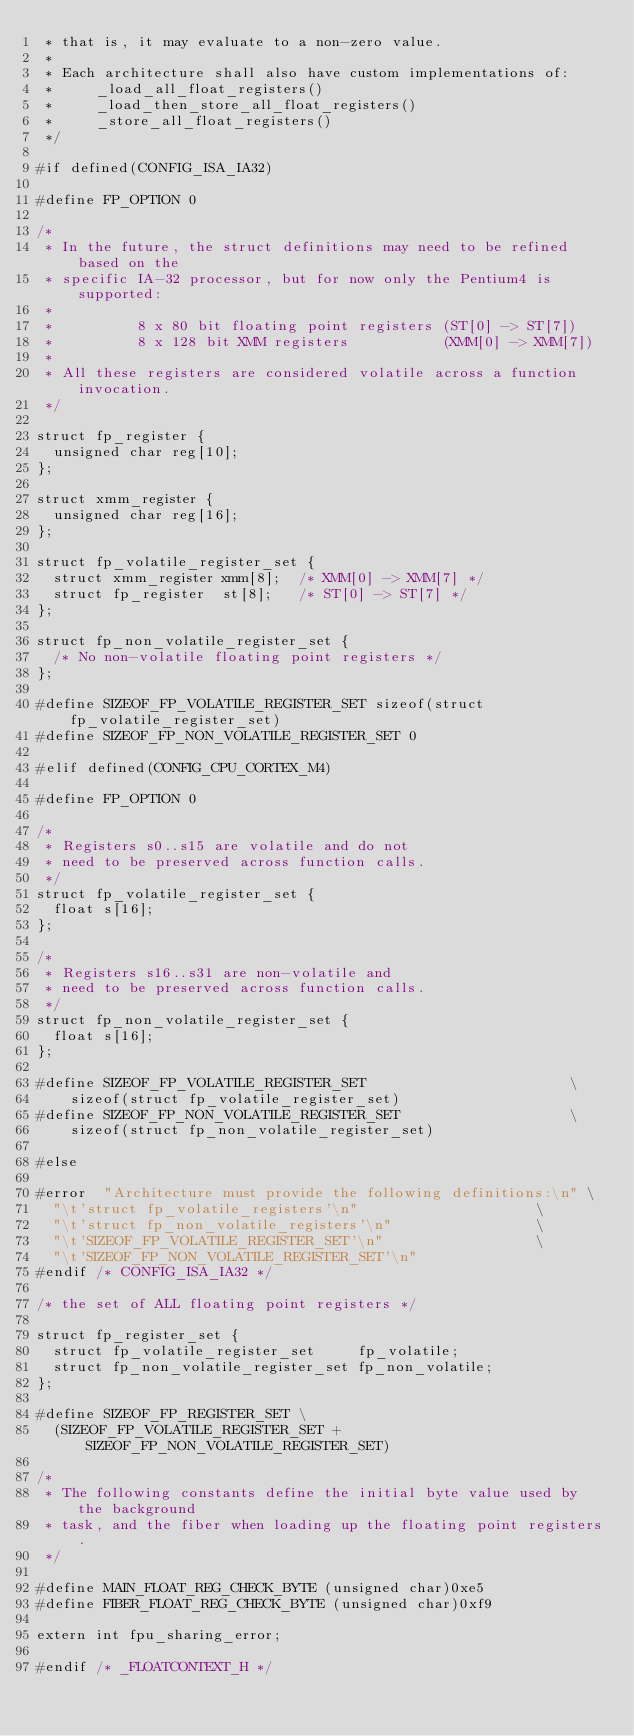Convert code to text. <code><loc_0><loc_0><loc_500><loc_500><_C_> * that is, it may evaluate to a non-zero value.
 *
 * Each architecture shall also have custom implementations of:
 *     _load_all_float_registers()
 *     _load_then_store_all_float_registers()
 *     _store_all_float_registers()
 */

#if defined(CONFIG_ISA_IA32)

#define FP_OPTION 0

/*
 * In the future, the struct definitions may need to be refined based on the
 * specific IA-32 processor, but for now only the Pentium4 is supported:
 *
 *          8 x 80 bit floating point registers (ST[0] -> ST[7])
 *          8 x 128 bit XMM registers           (XMM[0] -> XMM[7])
 *
 * All these registers are considered volatile across a function invocation.
 */

struct fp_register {
	unsigned char reg[10];
};

struct xmm_register {
	unsigned char reg[16];
};

struct fp_volatile_register_set {
	struct xmm_register xmm[8];  /* XMM[0] -> XMM[7] */
	struct fp_register  st[8];   /* ST[0] -> ST[7] */
};

struct fp_non_volatile_register_set {
	/* No non-volatile floating point registers */
};

#define SIZEOF_FP_VOLATILE_REGISTER_SET sizeof(struct fp_volatile_register_set)
#define SIZEOF_FP_NON_VOLATILE_REGISTER_SET 0

#elif defined(CONFIG_CPU_CORTEX_M4)

#define FP_OPTION 0

/*
 * Registers s0..s15 are volatile and do not
 * need to be preserved across function calls.
 */
struct fp_volatile_register_set {
	float s[16];
};

/*
 * Registers s16..s31 are non-volatile and
 * need to be preserved across function calls.
 */
struct fp_non_volatile_register_set {
	float s[16];
};

#define SIZEOF_FP_VOLATILE_REGISTER_SET                        \
		sizeof(struct fp_volatile_register_set)
#define SIZEOF_FP_NON_VOLATILE_REGISTER_SET                    \
		sizeof(struct fp_non_volatile_register_set)

#else

#error	"Architecture must provide the following definitions:\n" \
	"\t'struct fp_volatile_registers'\n"                     \
	"\t'struct fp_non_volatile_registers'\n"                 \
	"\t'SIZEOF_FP_VOLATILE_REGISTER_SET'\n"                  \
	"\t'SIZEOF_FP_NON_VOLATILE_REGISTER_SET'\n"
#endif /* CONFIG_ISA_IA32 */

/* the set of ALL floating point registers */

struct fp_register_set {
	struct fp_volatile_register_set     fp_volatile;
	struct fp_non_volatile_register_set fp_non_volatile;
};

#define SIZEOF_FP_REGISTER_SET \
	(SIZEOF_FP_VOLATILE_REGISTER_SET + SIZEOF_FP_NON_VOLATILE_REGISTER_SET)

/*
 * The following constants define the initial byte value used by the background
 * task, and the fiber when loading up the floating point registers.
 */

#define MAIN_FLOAT_REG_CHECK_BYTE (unsigned char)0xe5
#define FIBER_FLOAT_REG_CHECK_BYTE (unsigned char)0xf9

extern int fpu_sharing_error;

#endif /* _FLOATCONTEXT_H */
</code> 